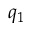Convert formula to latex. <formula><loc_0><loc_0><loc_500><loc_500>q _ { 1 }</formula> 